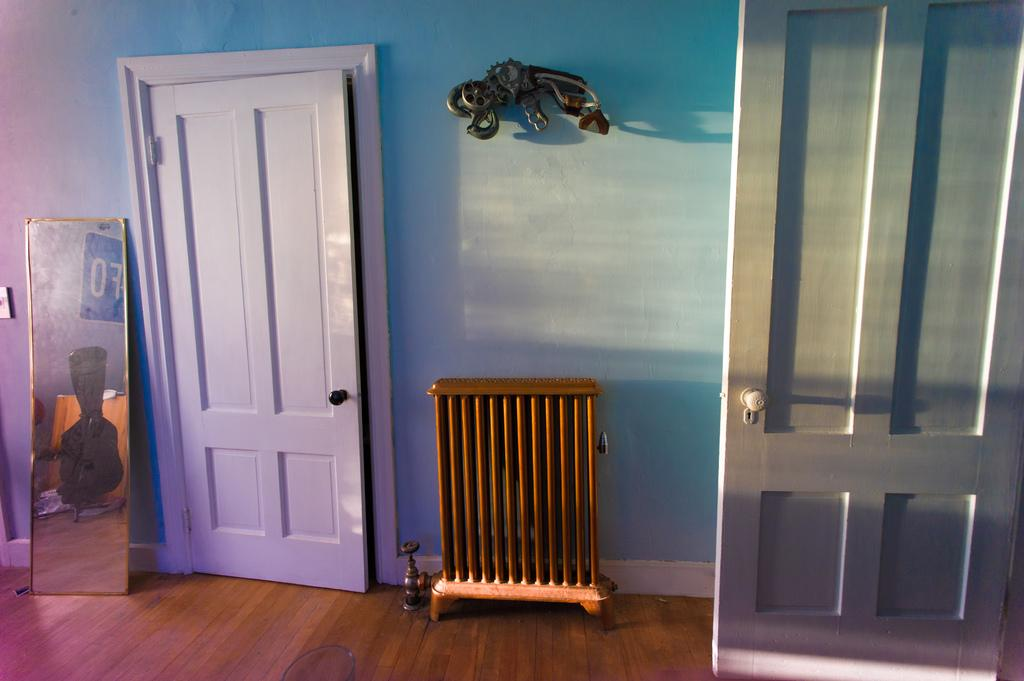What type of setting is shown in the image? The image depicts an inside view of a room. Are there any specific features in the room? Yes, there are doors in the room. What object can be used for self-reflection in the room? There is a mirror in the room. How does the wind affect the objects in the room in the image? There is no wind present in the image, as it is an inside view of a room. Can you see a kitty playing with a toy in the room in the image? There is no kitty or toy present in the image; it only shows a room with doors and a mirror. 